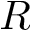<formula> <loc_0><loc_0><loc_500><loc_500>R</formula> 